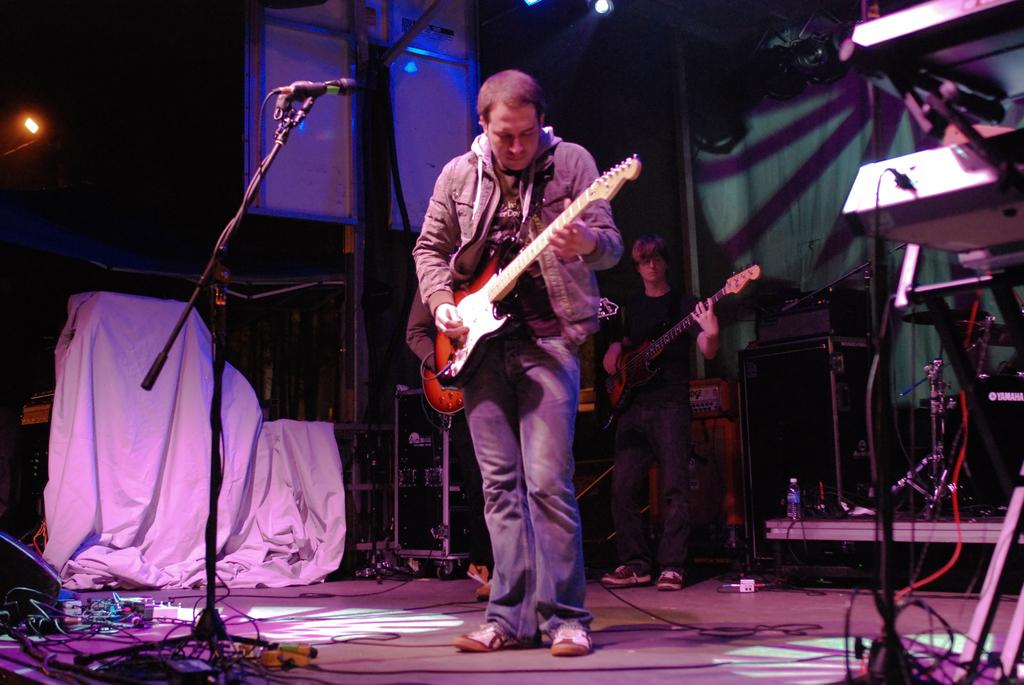Who or what is present in the image? There are people in the image. What are the people holding in the image? The people are holding guitars. Can you describe any specific objects near the people? There is a microphone in front of one of the people, and there are speakers in the background of the image. What else can be seen in the background of the image? There is a cloth and light visible in the background of the image. What sense is being used by the people in the image? The provided facts do not mention any specific senses being used by the people in the image. What is the purpose of the mouth in the image? The provided facts do not mention any mouths in the image, so it is not possible to determine the purpose of a mouth. 